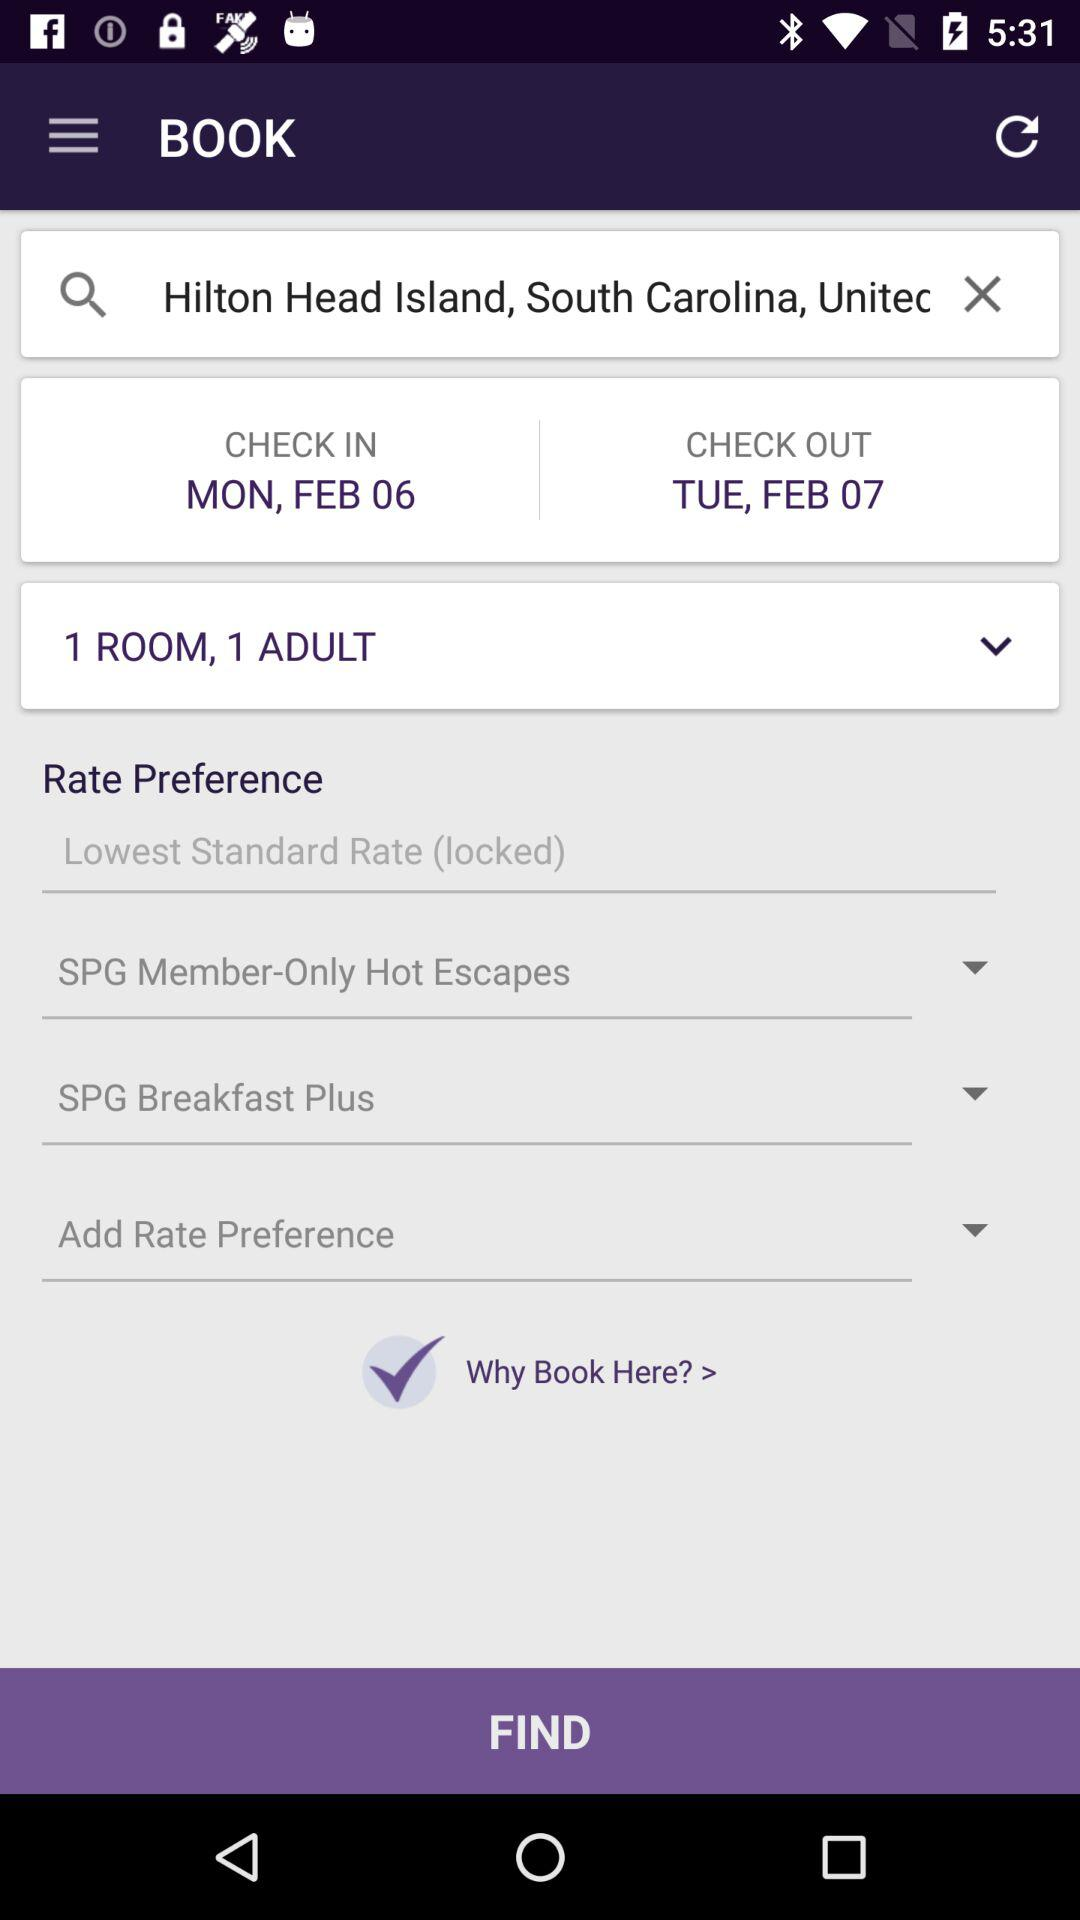What is the checkout date? The checkout date is Tuesday, February 7. 